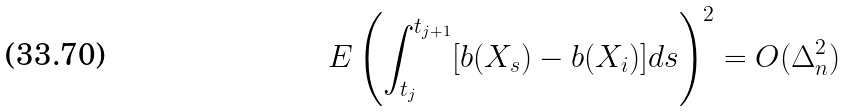<formula> <loc_0><loc_0><loc_500><loc_500>E \left ( \int _ { t _ { j } } ^ { t _ { j + 1 } } [ b ( X _ { s } ) - b ( X _ { i } ) ] d s \right ) ^ { 2 } = O ( \Delta _ { n } ^ { 2 } )</formula> 